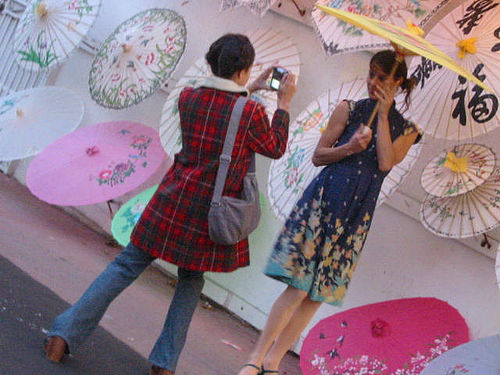<image>What character is on the umbrella? I don't know what character is on the umbrella. It could be a bird, flowers, pony, hello kitty, chinese, bugs bunny or japanese. What season is it? It is ambiguous what the current season is. It could be fall, winter, or spring. What season is it? I am not sure what season it is. It could be fall, winter or spring. What character is on the umbrella? I am not sure which character is on the umbrella. It can be seen 'bird', 'flowers', 'pony', 'hello kitty', 'chinese', 'not sure', 'none', 'bugs bunny' or 'japanese'. 